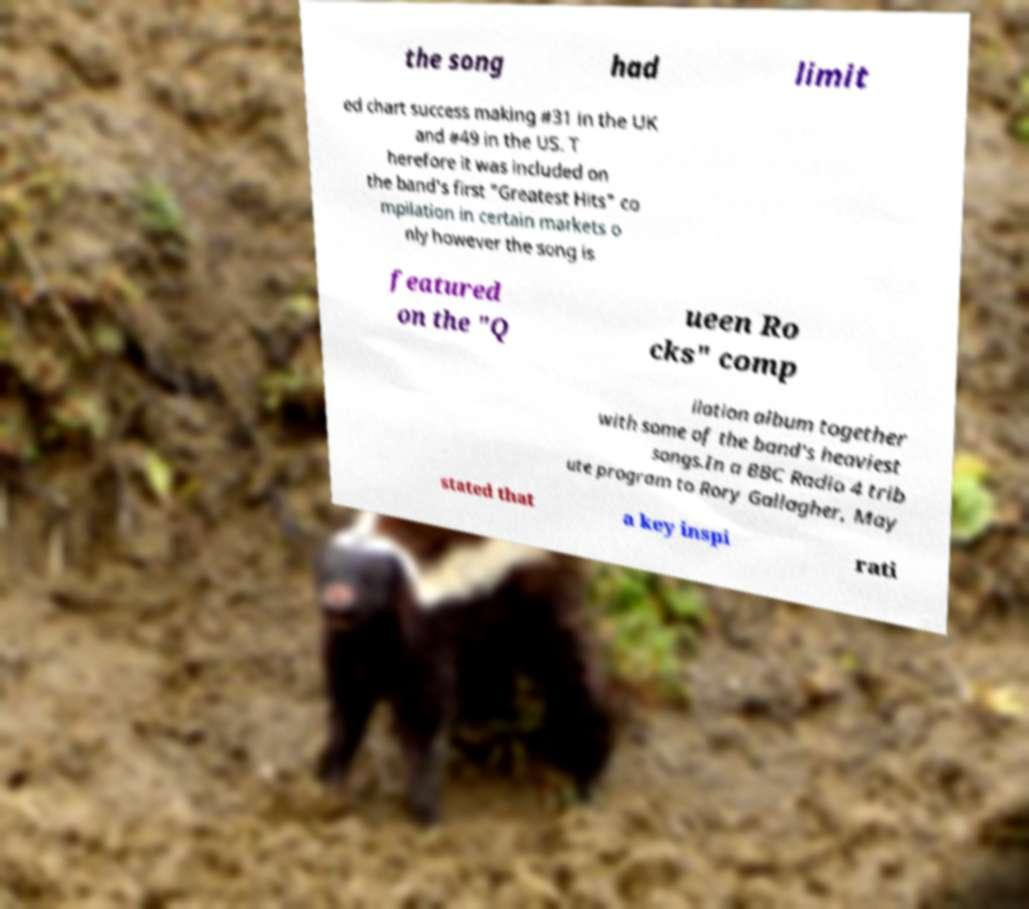Can you read and provide the text displayed in the image?This photo seems to have some interesting text. Can you extract and type it out for me? the song had limit ed chart success making #31 in the UK and #49 in the US. T herefore it was included on the band's first "Greatest Hits" co mpilation in certain markets o nly however the song is featured on the "Q ueen Ro cks" comp ilation album together with some of the band's heaviest songs.In a BBC Radio 4 trib ute program to Rory Gallagher, May stated that a key inspi rati 